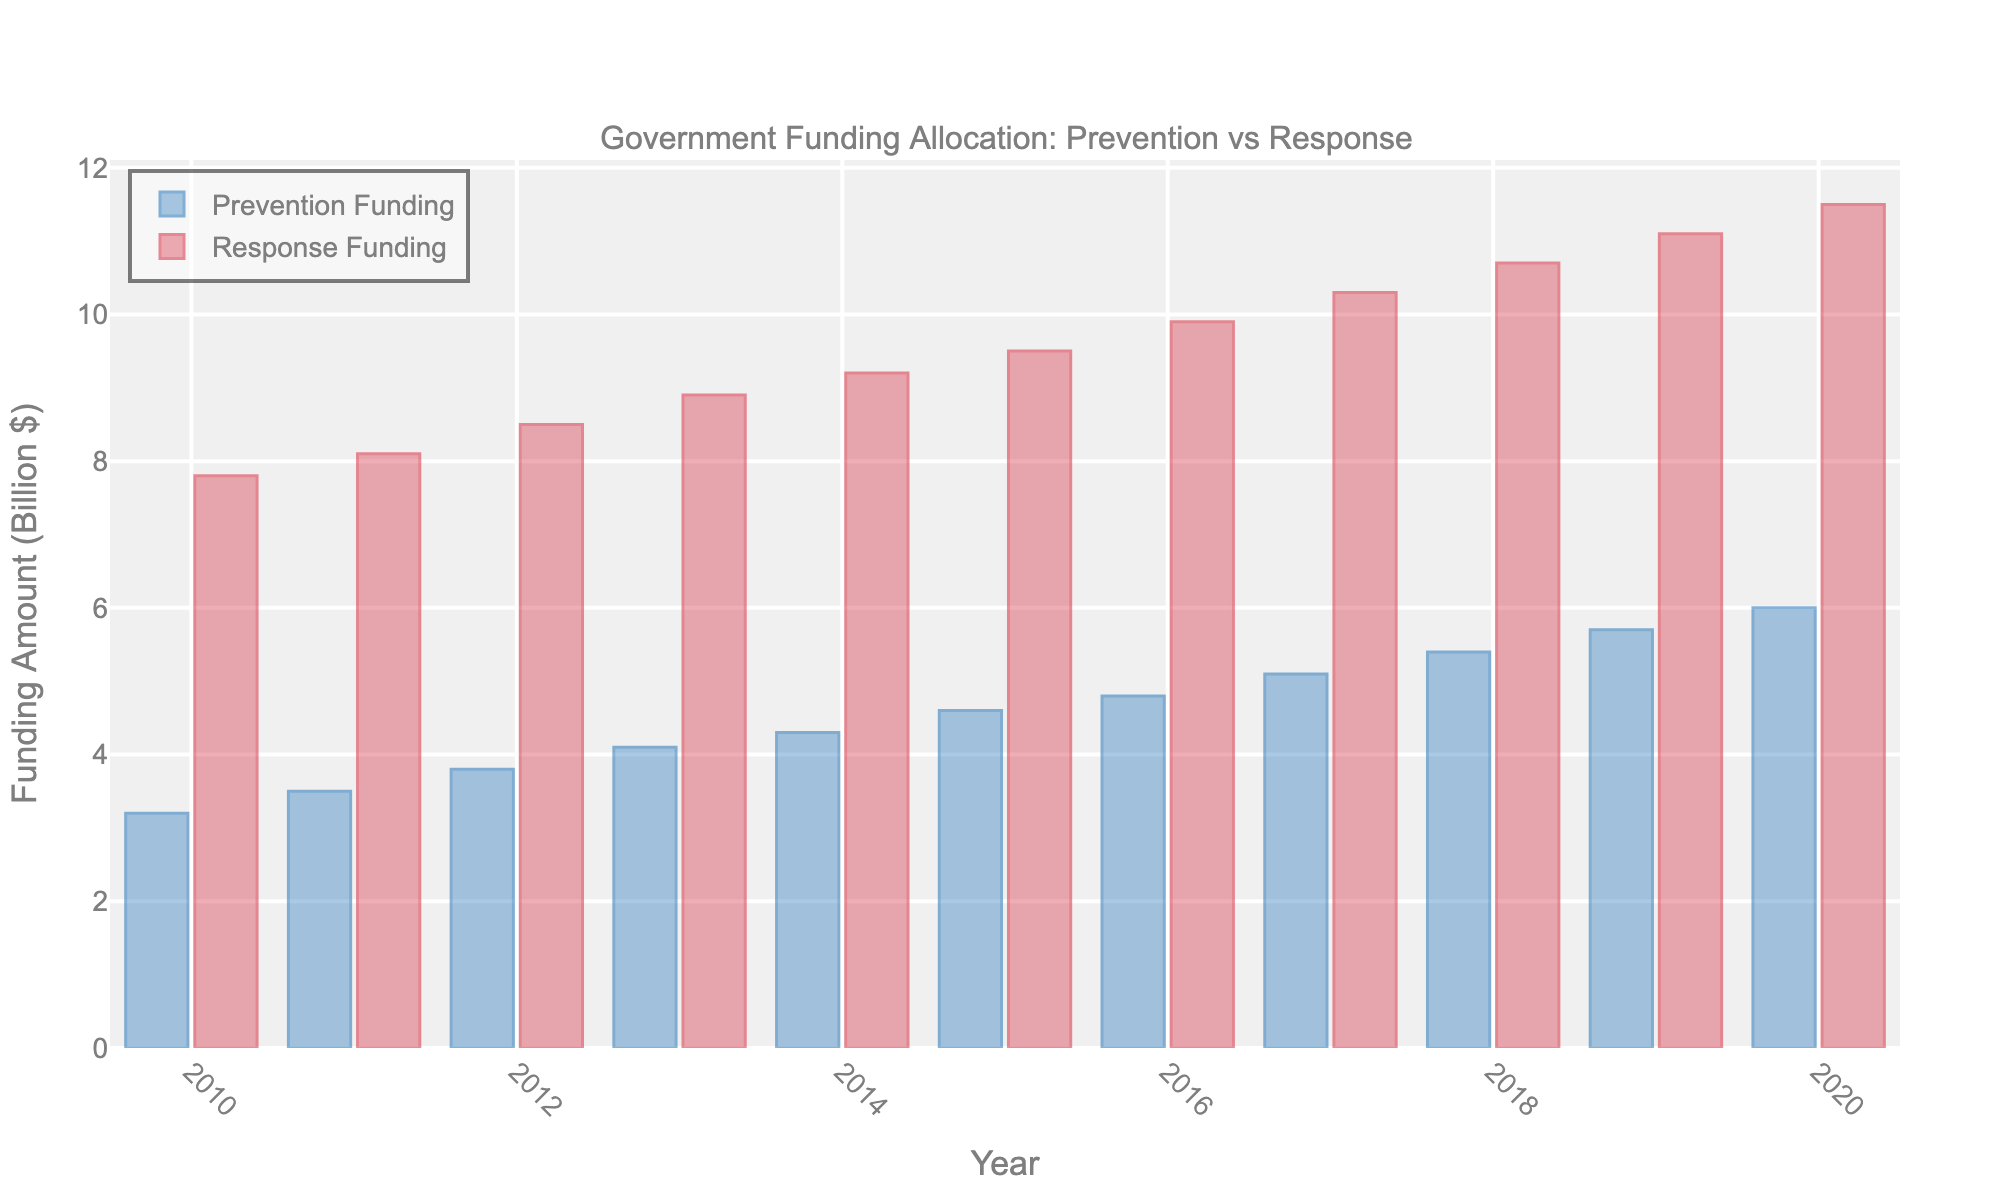Which year had the smallest difference between Prevention Funding and Response Funding? Look at the height of the bars for both Prevention and Response for each year, then calculate the differences (e.g., for 2010, it's 7.8 - 3.2 = 4.6). The year with the smallest difference is 2020 (11.5 - 6.0 = 5.5, which is the smallest gap compared to other years).
Answer: 2020 What is the trend of Prevention Funding from 2010 to 2020? Observe the increasing height of the blue bars representing Prevention Funding over the years 2010 to 2020. Each year shows a consistent increase.
Answer: Increasing How much total funding was allocated for both Prevention and Response in 2015? Add the values of Prevention Funding and Response Funding for the year 2015. For 2015: Prevention = 4.6, Response = 9.5. Hence, 4.6 + 9.5 = 14.1.
Answer: 14.1 billion dollars In which year did the Prevention Funding first exceed 5 billion dollars? Check the blue bars until you find the first year where the Prevention Funding bar height is greater than 5 billion dollars. This occurs in 2017, where it's 5.1 billion dollars.
Answer: 2017 By how much did Response Funding exceed Prevention Funding in 2010? Calculate the difference between Response Funding and Prevention Funding for 2010. Response = 7.8, Prevention = 3.2. Therefore, 7.8 - 3.2 = 4.6.
Answer: 4.6 billion dollars What is the average Response Funding from 2010 to 2020? Sum the Response Funding values from 2010 to 2020 and then divide by the number of years (11). (7.8+8.1+8.5+8.9+9.2+9.5+9.9+10.3+10.7+11.1+11.5)/11 = 103.5/11 = 9.41.
Answer: 9.41 billion dollars Which year had the highest Prevention Funding? Identify the year where the highest blue bar appears. This is in 2020 when the Prevention Funding reached 6.0 billion dollars.
Answer: 2020 In 2013, by what factor was the Response Funding higher than the Prevention Funding? Divide the Response Funding by the Prevention Funding for 2013. Response = 8.9, Prevention = 4.1. Therefore, 8.9 / 4.1 ≈ 2.17.
Answer: Approximately 2.17 